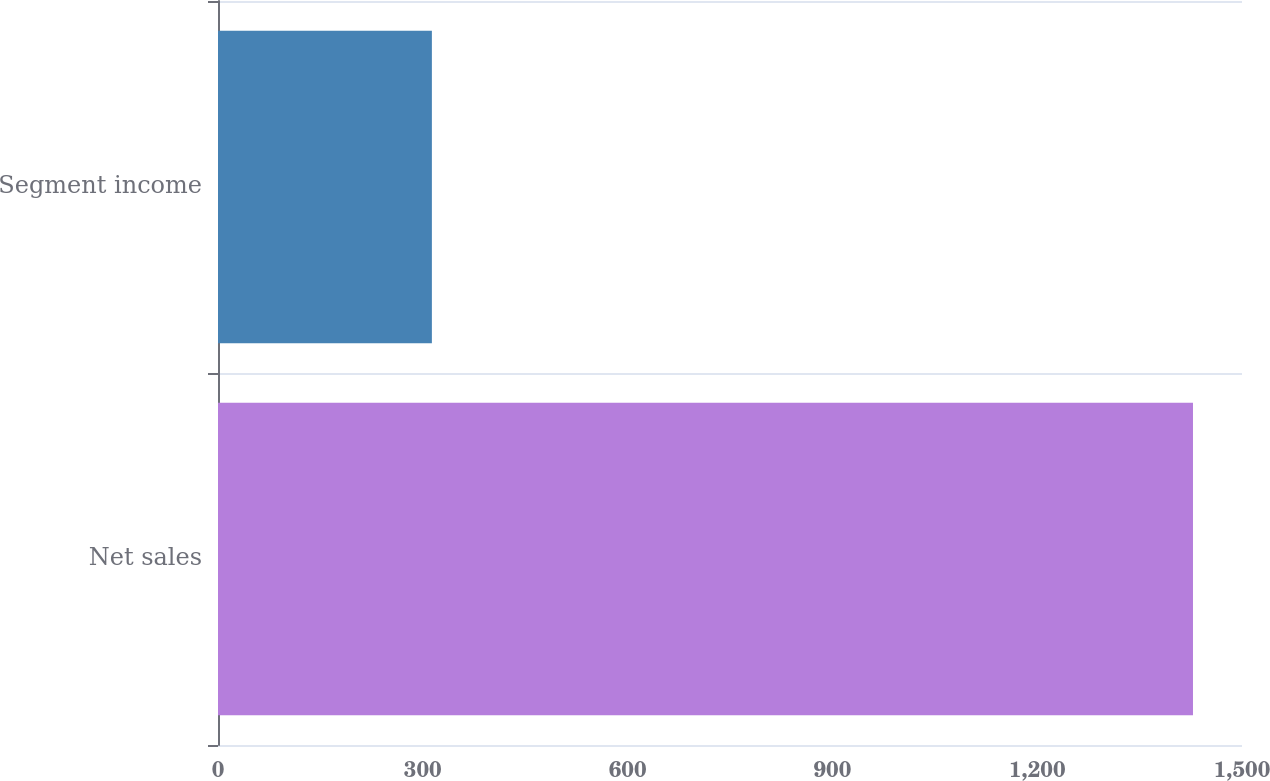<chart> <loc_0><loc_0><loc_500><loc_500><bar_chart><fcel>Net sales<fcel>Segment income<nl><fcel>1428.2<fcel>313.3<nl></chart> 